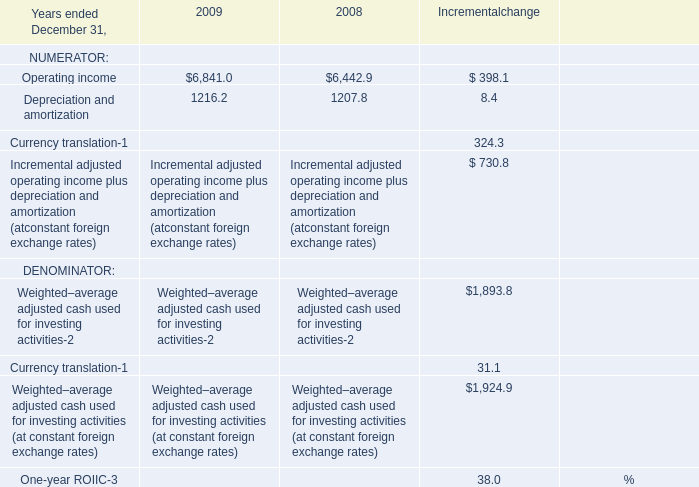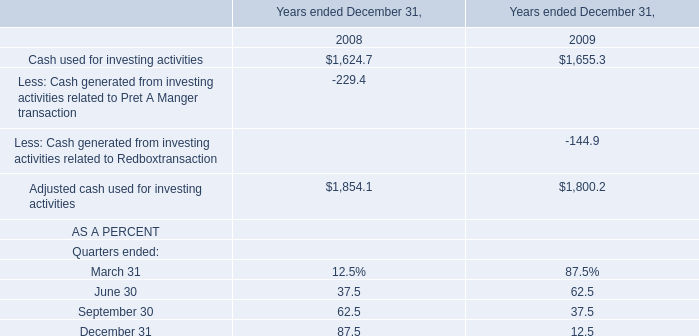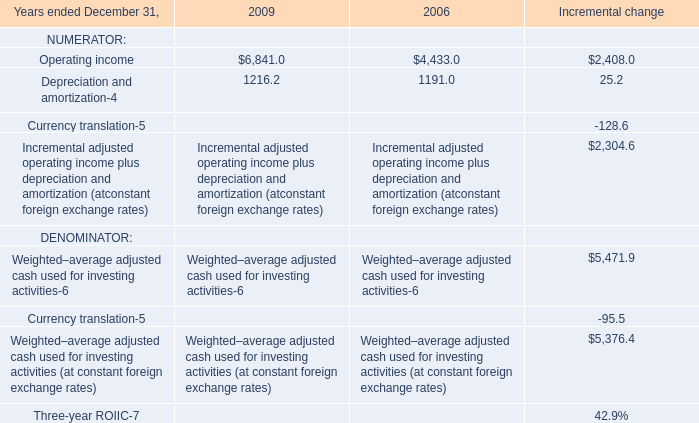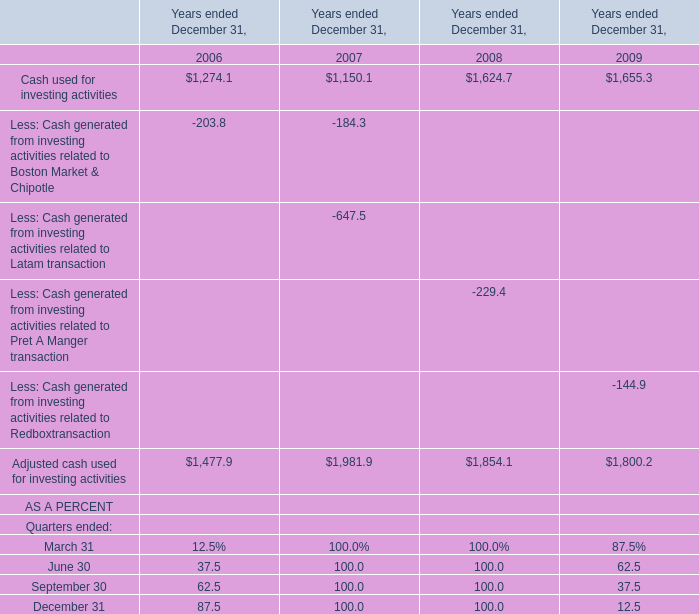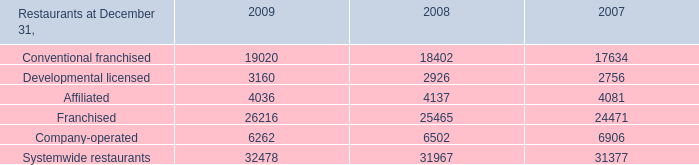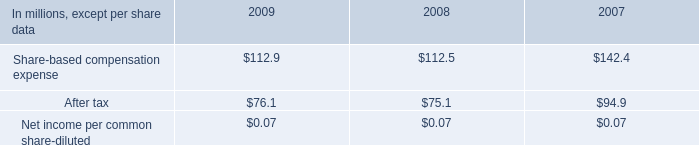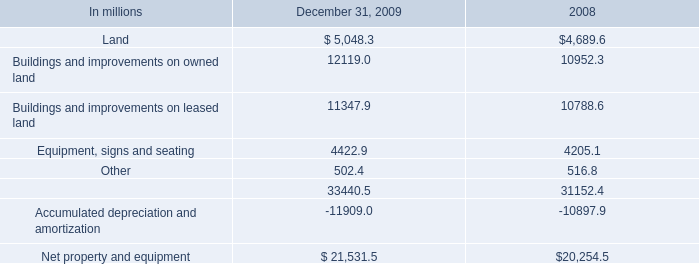What was the total amount of NUMERATOR greater than 0 in 2006? 
Computations: (4433.0 + 1191.0)
Answer: 5624.0. 